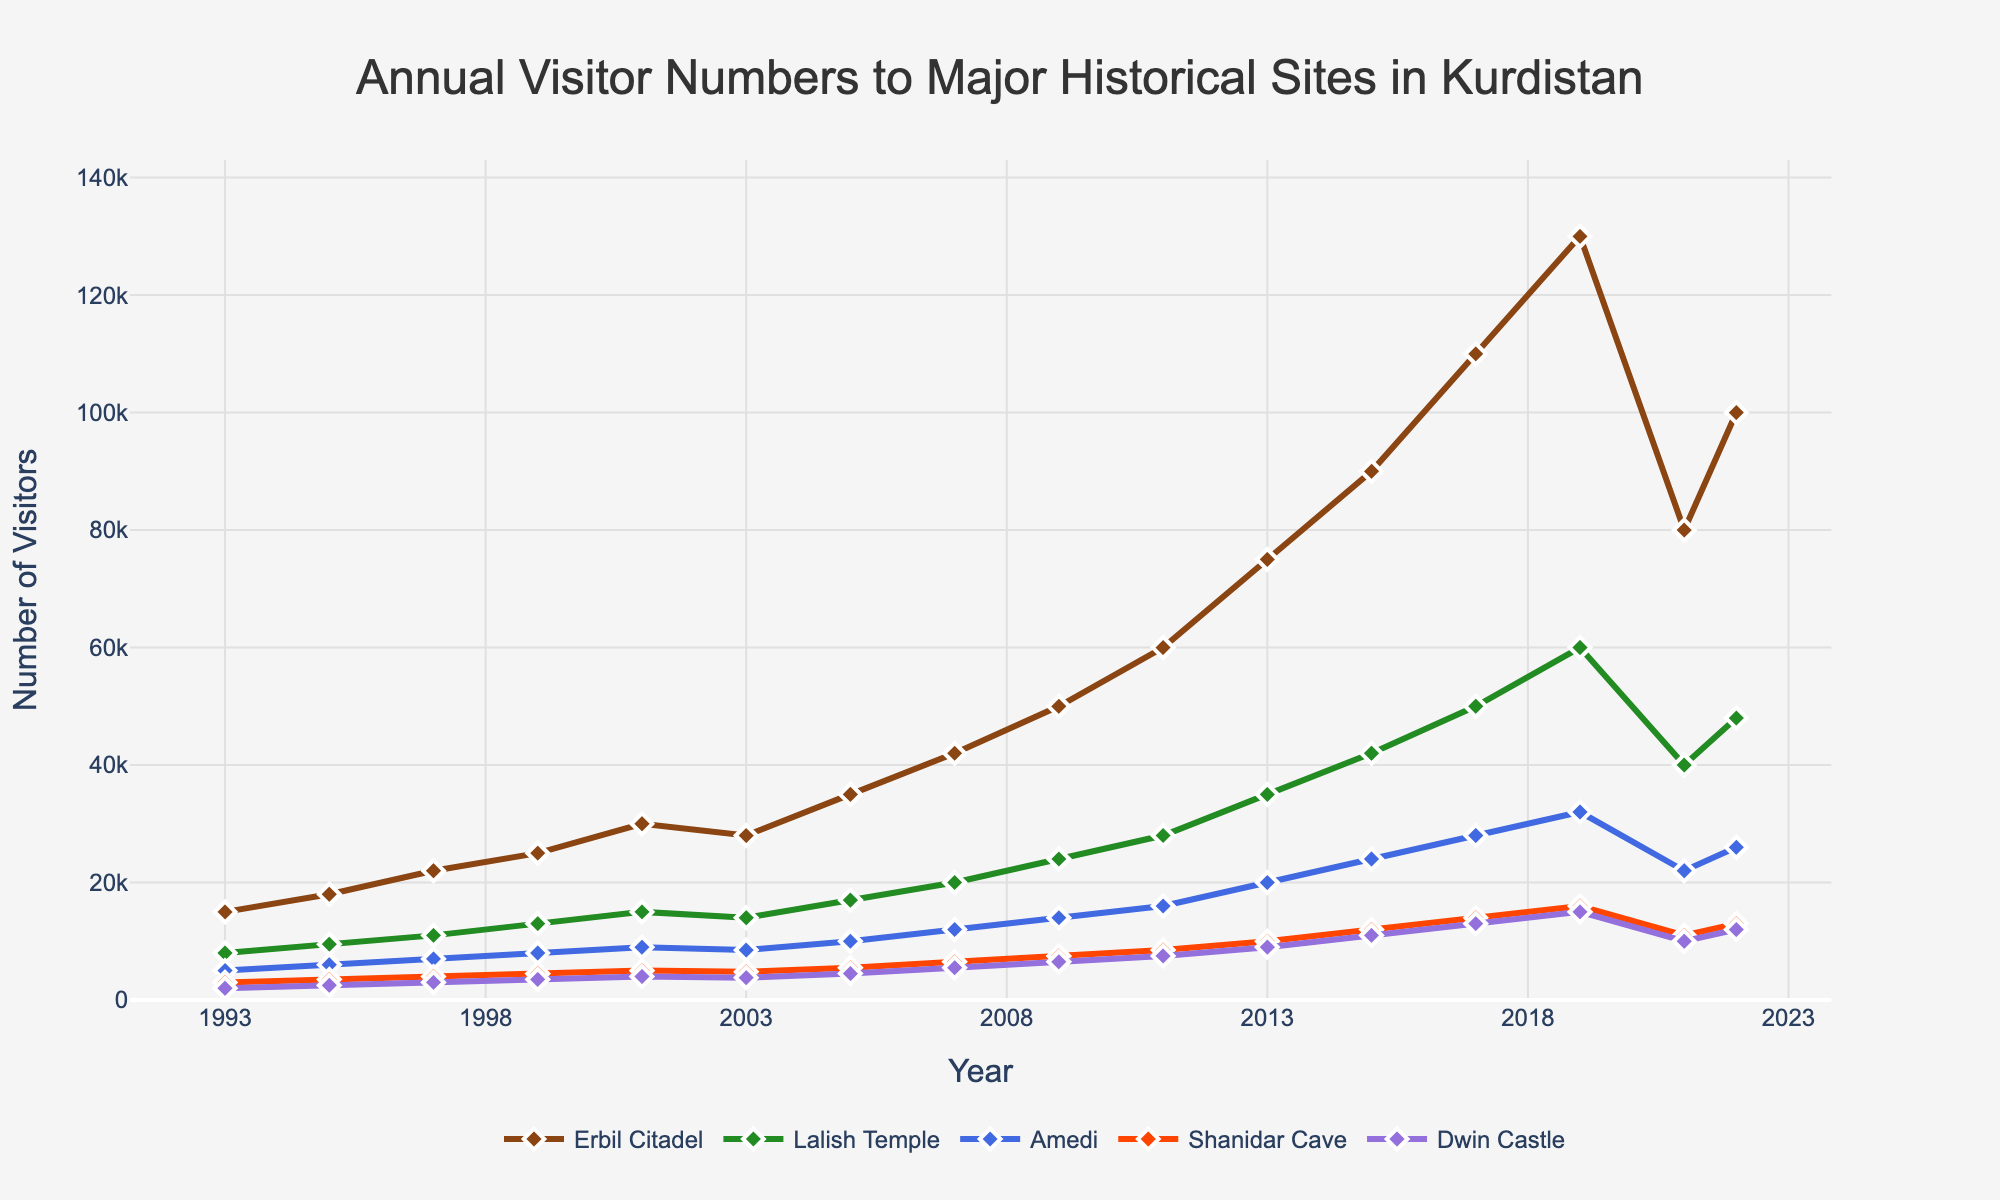What was the number of visitors to Erbil Citadel in 2022? Refer to the data point for Erbil Citadel in the year 2022. The value is given directly in the figure.
Answer: 100,000 How did the visitor numbers to Shanidar Cave change from 1993 to 2022? Compare the visitor numbers to Shanidar Cave between 1993 and 2022. Look at the figures for both years and compute the difference.
Answer: Increase from 3,000 to 13,000 Which historical site had the highest increase in visitors from 2019 to 2022? Examine the visitor numbers for each site in 2019 and 2022. Calculate the increase for each site by subtracting the 2019 value from the 2022 value, and identify the site with the maximum increase.
Answer: Erbil Citadel Compare the visitor numbers for Lalish Temple and Dwin Castle in 2013. Which site received more visitors? Check the visitor numbers for both Lalish Temple and Dwin Castle in the year 2013. Then compare the two values to see which is higher.
Answer: Lalish Temple What is the average number of visitors to Amedi from 1993 to 2022? Sum the visitor numbers to Amedi for each year from 1993 to 2022, and then divide the total by the number of years (30).
Answer: 12,067 In which year did Erbil Citadel surpass 100,000 visitors for the first time? Look at the trend line for Erbil Citadel and identify the first year where the visitor numbers exceeded 100,000.
Answer: 2017 How does the trend in visitor numbers to Shanidar Cave compare to Lalish Temple between 2017 and 2021? Analyze the trend lines for Shanidar Cave and Lalish Temple between 2017 and 2021. Observe whether the trends are increasing, decreasing, or fluctuating.
Answer: Both decreased Which site had the largest fluctuation in visitor numbers over the 30 years? Compare the range (difference between the highest and lowest values) of visitor numbers for all sites over the 30 years. Identify the site with the greatest range.
Answer: Erbil Citadel What is the total increase in visitors to Dwin Castle from 1993 to 2005? Calculate the increase in visitors to Dwin Castle each year from 1993 to 2005 and sum these values.
Answer: Increase by 2,500 By how much did the visitor numbers to Lalish Temple increase between 1999 and 2001? Determine the visitor numbers for Lalish Temple in 1999 and 2001, then find the difference between these two values.
Answer: Increase by 2,000 